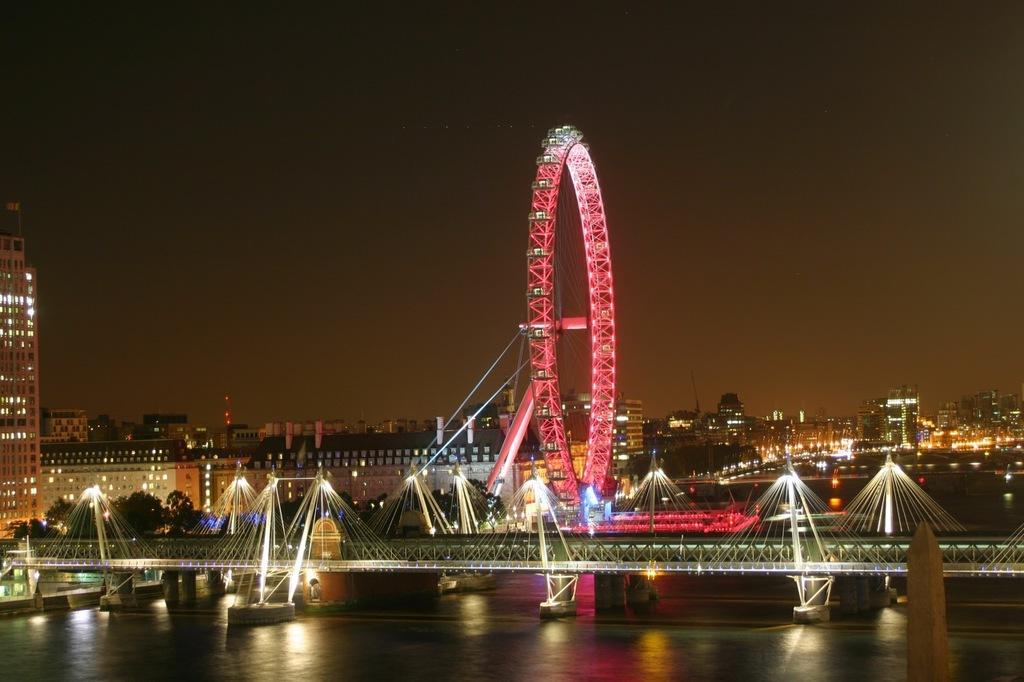How would you summarize this image in a sentence or two? This image is taken during the night time. In this image we can see the bridge, giant wheel with lights. We can also see many buildings with lightning. In the background we can see the sky and at the bottom we can see the water. 